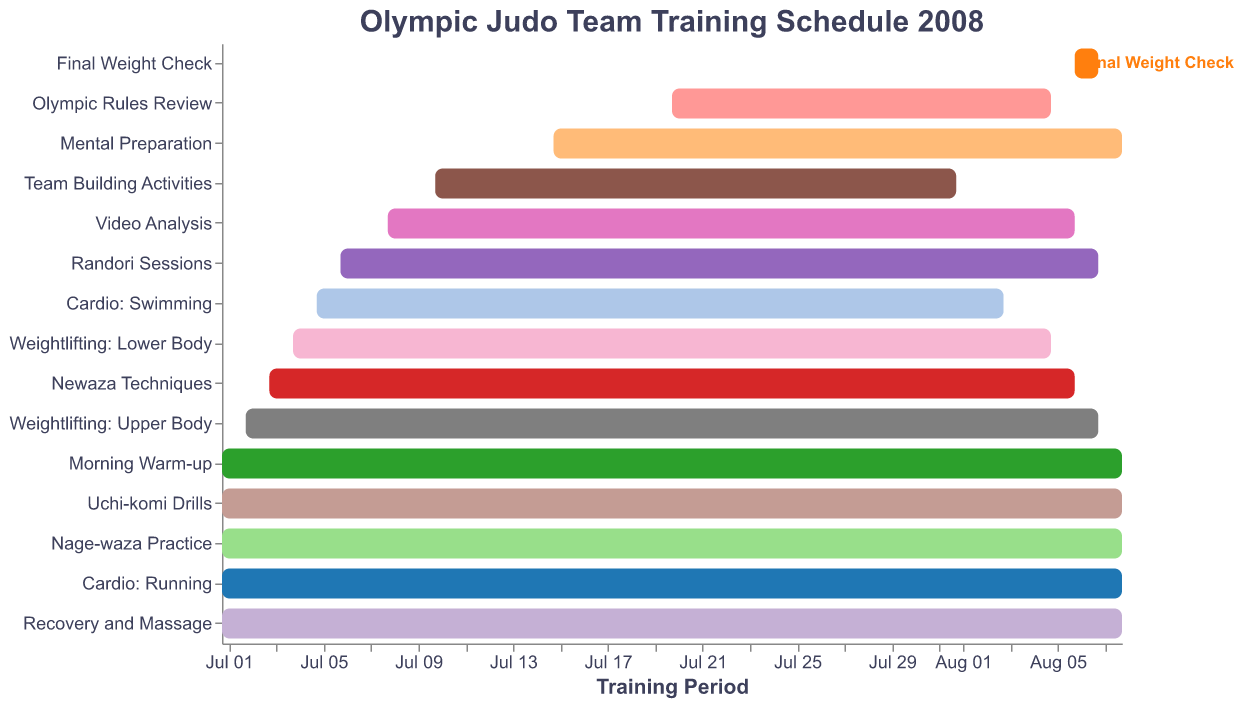What's the title of the chart? The title of the chart is displayed at the top and reads "Olympic Judo Team Training Schedule 2008".
Answer: Olympic Judo Team Training Schedule 2008 How long is the duration for the training task "Cardio: Running"? Locate the "Cardio: Running" bar and note its start and end dates. It starts on July 1 and ends on August 8.
Answer: July 1 to August 8 Which training task starts the latest in July? Review the start dates for all tasks listed in July. "Mental Preparation" starts on July 15, which is later than any other.
Answer: Mental Preparation Which training tasks end on August 6? Identify the tasks with an end date of August 6. Both "Newaza Techniques" and "Video Analysis" end on this date.
Answer: Newaza Techniques, Video Analysis What is the total duration for "Team Building Activities"? "Team Building Activities" starts on July 10 and ends on August 1. Counting the days, it spans 23 days.
Answer: 23 days Which weightlifting training has a longer duration: Upper Body or Lower Body? Compare the start and end dates of "Weightlifting: Upper Body" (July 2 to August 7) and "Weightlifting: Lower Body" (July 4 to August 5). The Upper Body has a longer duration.
Answer: Weightlifting: Upper Body How many training tasks overlap with "Final Weight Check"? "Final Weight Check" runs from August 6 to August 7. Tasks intersecting this period: "Newaza Techniques", "Weightlifting: Upper Body", "Randori Sessions", and "Video Analysis".
Answer: Four tasks By how many days does "Nage-waza Practice" exceed "Olympic Rules Review"? "Nage-waza Practice" runs from July 1 to August 8 (39 days), while "Olympic Rules Review" runs from July 20 to August 5 (17 days). Calculate the difference: 39 - 17 = 22.
Answer: 22 days Which training task starts and ends within July only? Find the tasks with both start and end dates in July. "Olympic Rules Review" (July 20 to August 5) and "Team Building Activities" (July 10 to August 1) are the closest but span into August. None of the tasks end only within July.
Answer: None 